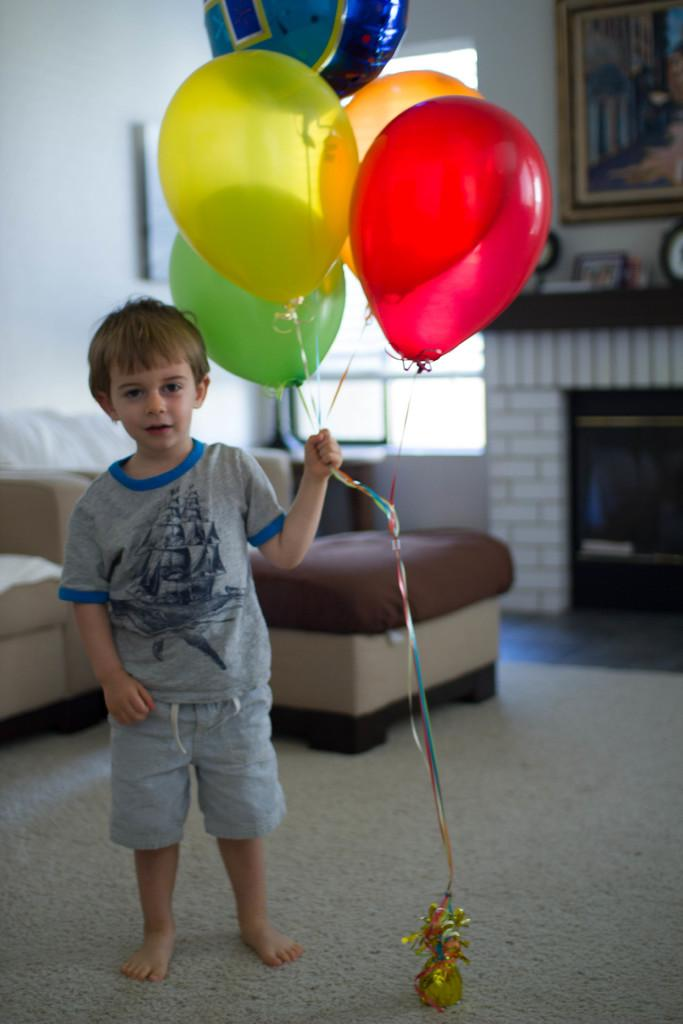What is the boy in the image doing? The boy is standing on the road in the image. What is the boy holding in the image? The boy is holding balloons in the image. What can be seen in the background of the image? There is a sofa, a window, a photo frame, and a wall in the background of the image. Can you see any insects crawling on the boy's stomach in the image? There are no insects or any reference to a stomach in the image. 